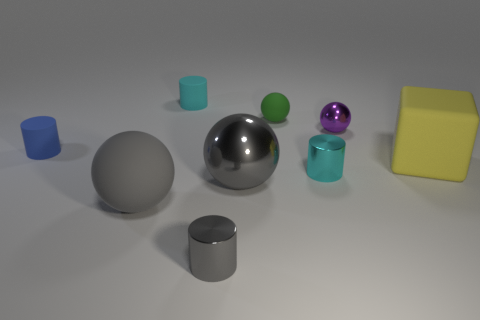Are there more tiny green rubber things than large cyan balls?
Give a very brief answer. Yes. There is a tiny gray thing in front of the metallic ball behind the cyan thing in front of the large yellow block; what is it made of?
Provide a succinct answer. Metal. Do the big shiny object and the rubber block have the same color?
Give a very brief answer. No. Are there any rubber things of the same color as the large rubber ball?
Your answer should be very brief. No. The green matte object that is the same size as the blue object is what shape?
Provide a short and direct response. Sphere. Are there fewer small cyan cylinders than cyan rubber objects?
Offer a very short reply. No. What number of other green matte balls are the same size as the green rubber sphere?
Give a very brief answer. 0. What is the shape of the large matte thing that is the same color as the big metal sphere?
Your answer should be very brief. Sphere. What material is the yellow cube?
Your answer should be very brief. Rubber. There is a cyan thing that is behind the small green sphere; what size is it?
Offer a terse response. Small. 